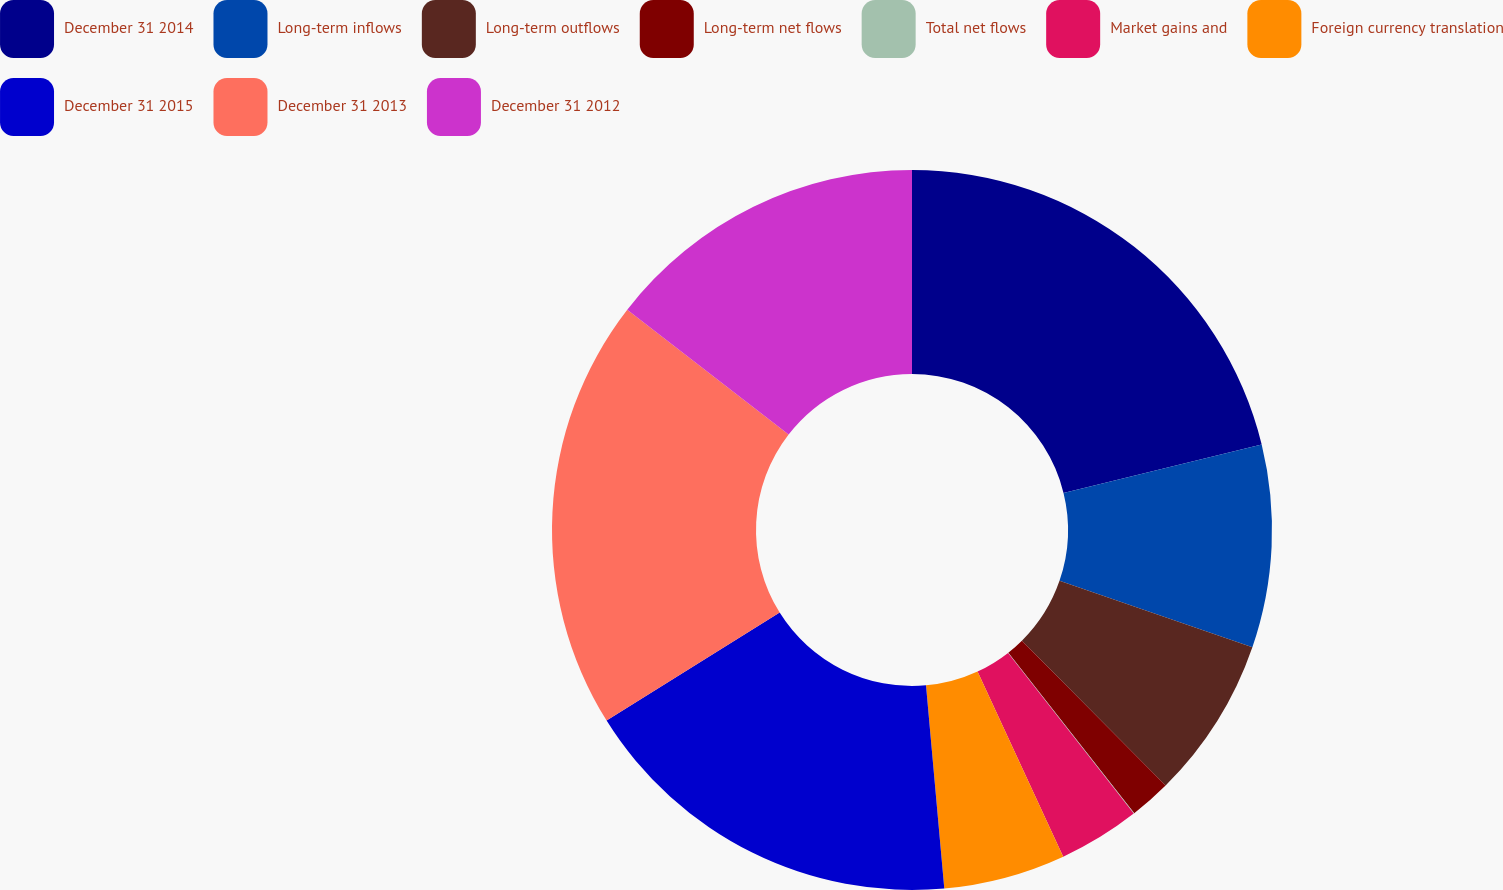Convert chart to OTSL. <chart><loc_0><loc_0><loc_500><loc_500><pie_chart><fcel>December 31 2014<fcel>Long-term inflows<fcel>Long-term outflows<fcel>Long-term net flows<fcel>Total net flows<fcel>Market gains and<fcel>Foreign currency translation<fcel>December 31 2015<fcel>December 31 2013<fcel>December 31 2012<nl><fcel>21.18%<fcel>9.1%<fcel>7.28%<fcel>1.85%<fcel>0.03%<fcel>3.66%<fcel>5.47%<fcel>17.55%<fcel>19.36%<fcel>14.52%<nl></chart> 